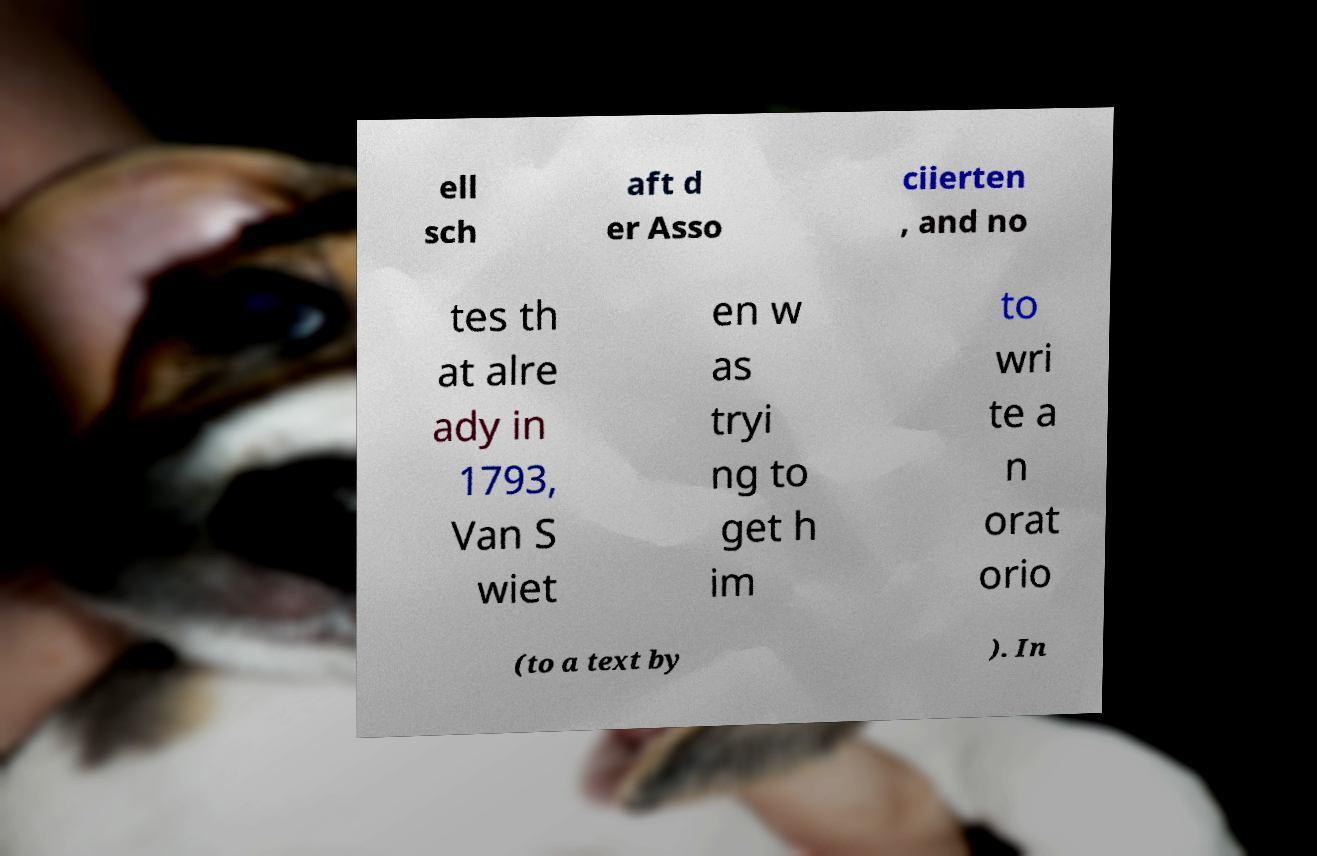Please read and relay the text visible in this image. What does it say? ell sch aft d er Asso ciierten , and no tes th at alre ady in 1793, Van S wiet en w as tryi ng to get h im to wri te a n orat orio (to a text by ). In 